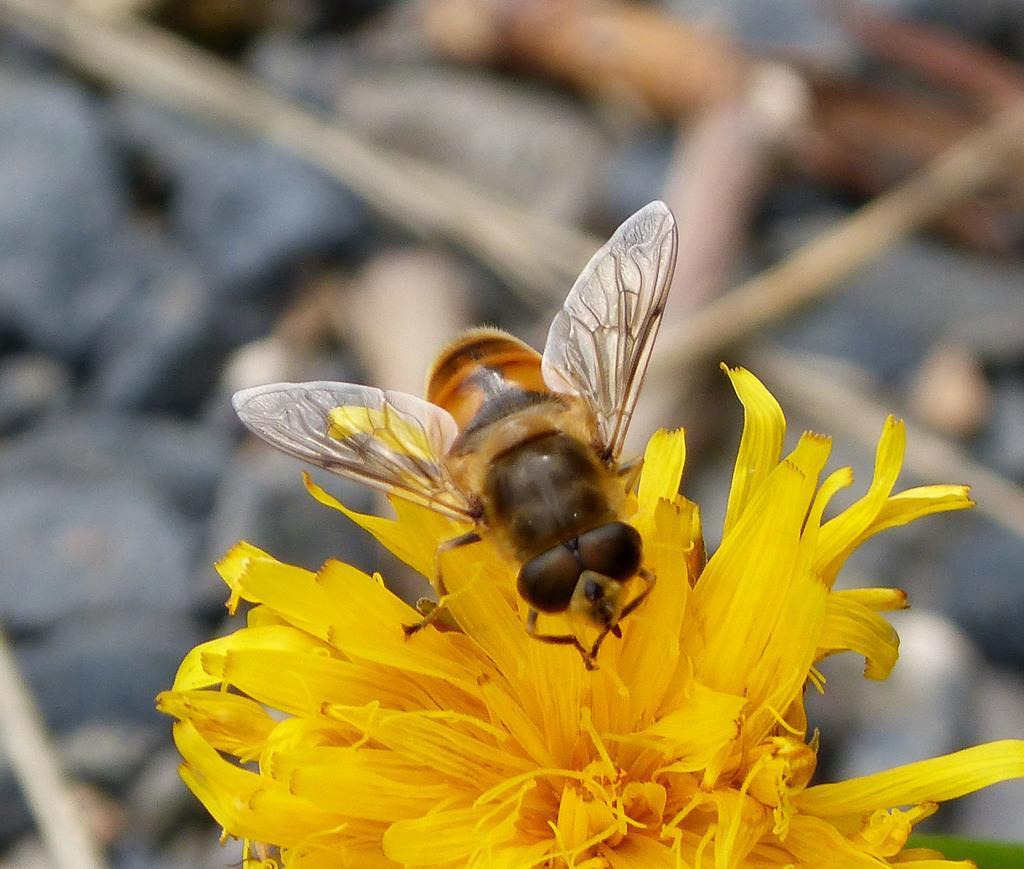How would you summarize this image in a sentence or two? In the image there is an insect lying on a flower and the background of the insect is blur. 